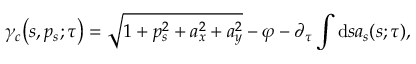Convert formula to latex. <formula><loc_0><loc_0><loc_500><loc_500>\gamma _ { c } { \left ( s , p _ { s } ; \tau \right ) } = { \sqrt { 1 + p _ { s } ^ { 2 } + a _ { x } ^ { 2 } + a _ { y } ^ { 2 } } } - \varphi - \partial _ { \tau } \int d s a _ { s } { \left ( s ; \tau \right ) } ,</formula> 